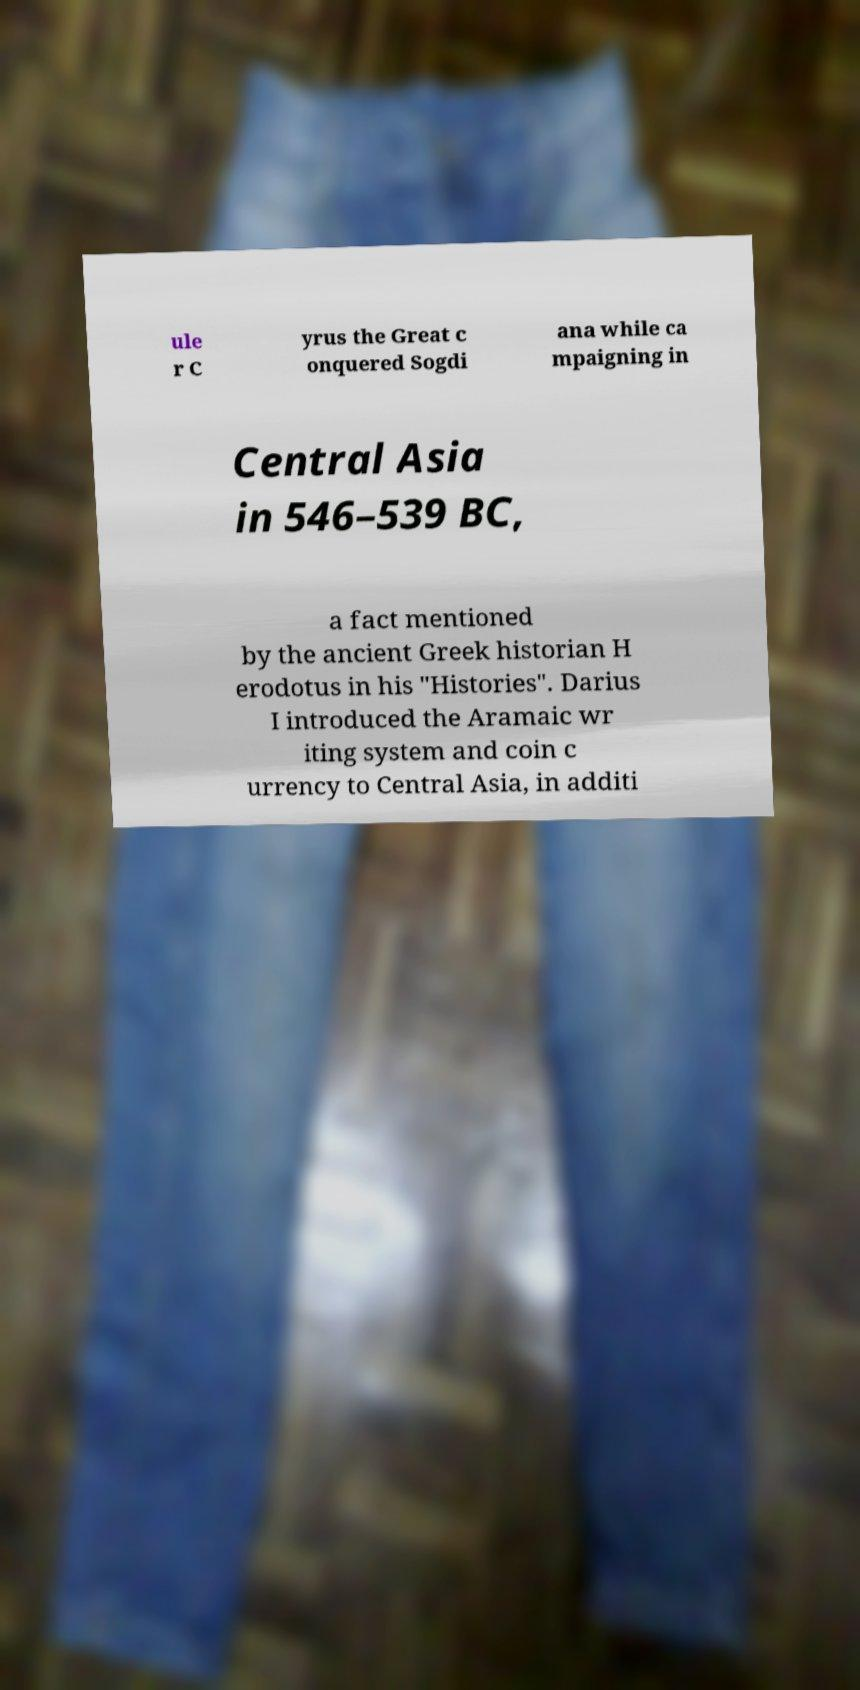Could you extract and type out the text from this image? ule r C yrus the Great c onquered Sogdi ana while ca mpaigning in Central Asia in 546–539 BC, a fact mentioned by the ancient Greek historian H erodotus in his "Histories". Darius I introduced the Aramaic wr iting system and coin c urrency to Central Asia, in additi 